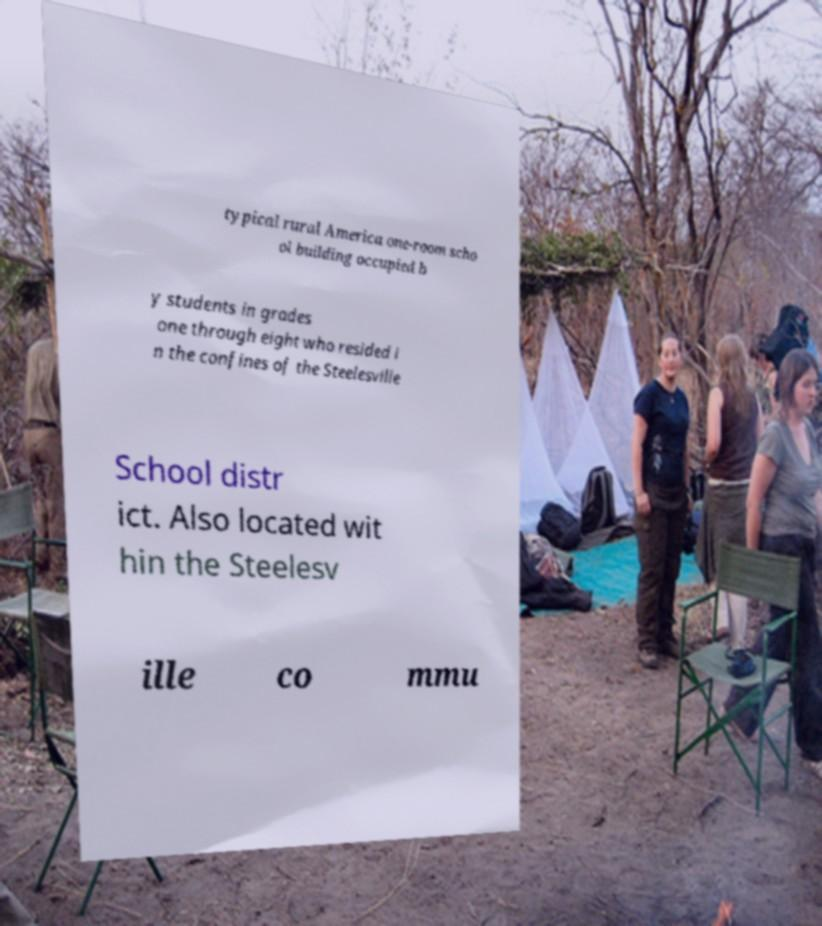I need the written content from this picture converted into text. Can you do that? typical rural America one-room scho ol building occupied b y students in grades one through eight who resided i n the confines of the Steelesville School distr ict. Also located wit hin the Steelesv ille co mmu 